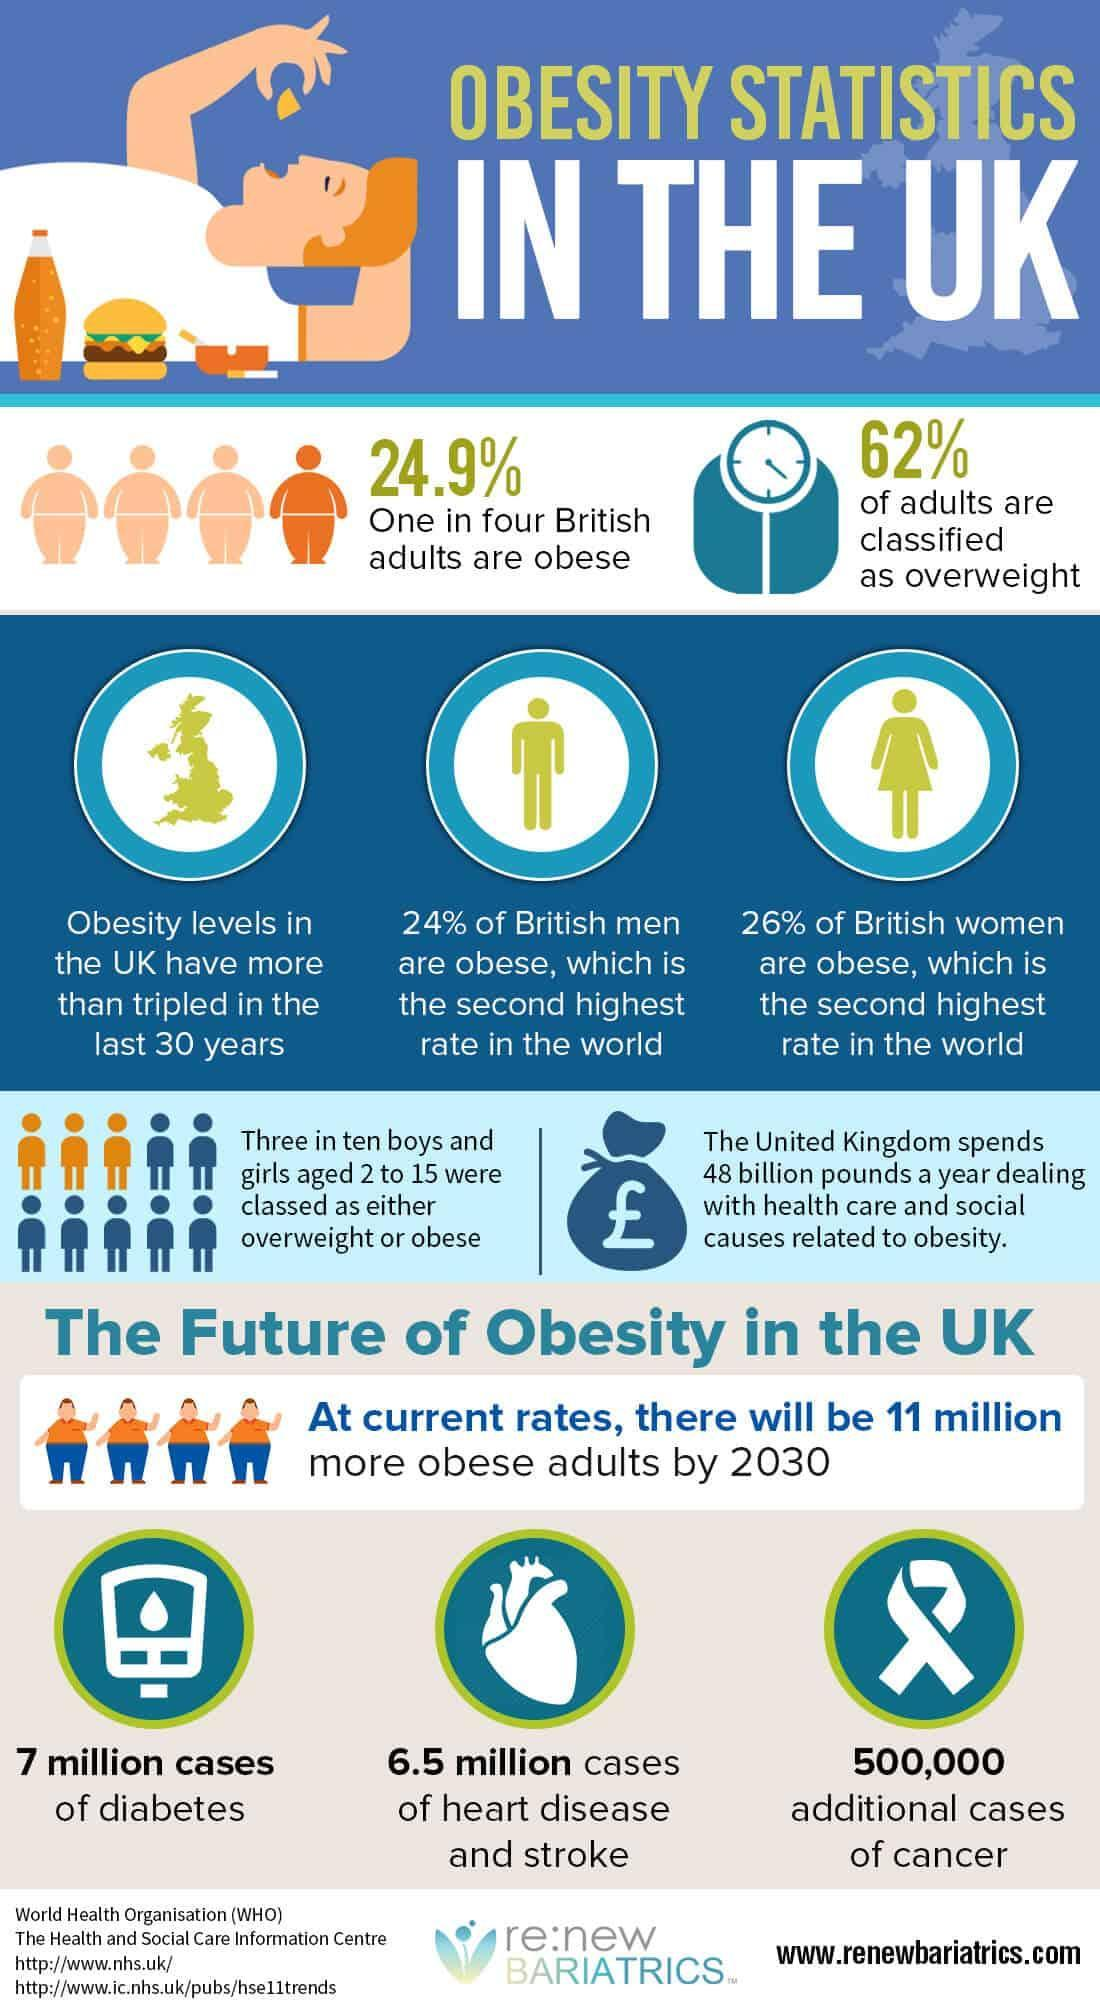What percentage of boys and girls aged 2 to 15 were classed as either overweight or obese?
Answer the question with a short phrase. 30% How many adults are overweight? 62% 